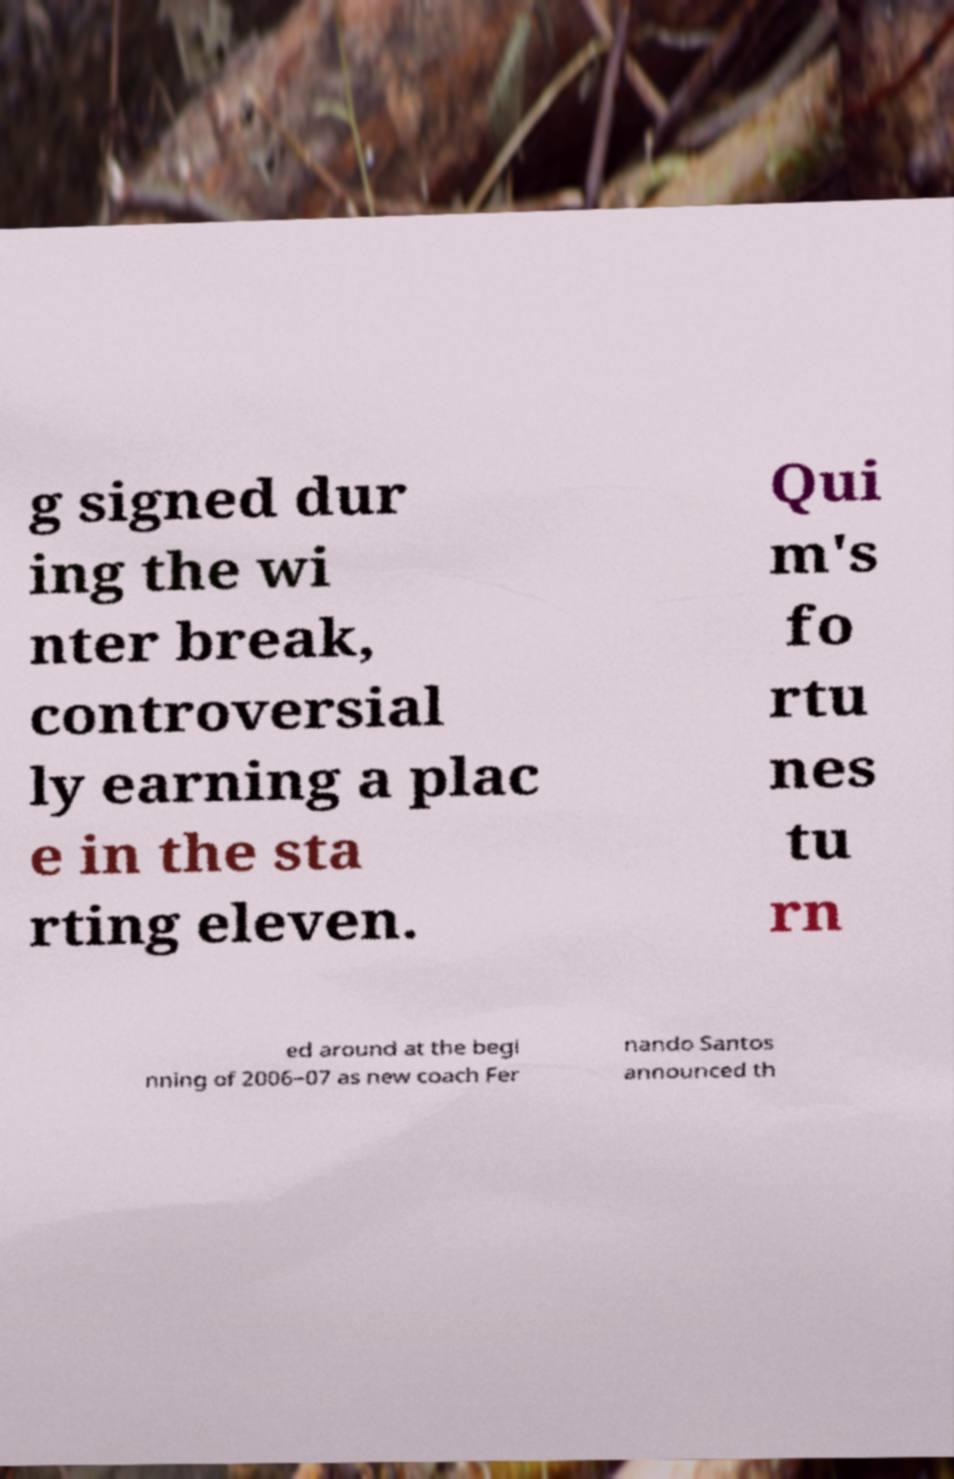Could you extract and type out the text from this image? g signed dur ing the wi nter break, controversial ly earning a plac e in the sta rting eleven. Qui m's fo rtu nes tu rn ed around at the begi nning of 2006–07 as new coach Fer nando Santos announced th 